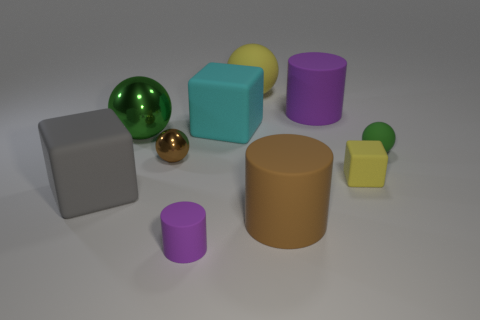Subtract all gray matte cubes. How many cubes are left? 2 Subtract all brown cylinders. How many green spheres are left? 2 Subtract all brown spheres. How many spheres are left? 3 Subtract 3 spheres. How many spheres are left? 1 Subtract all balls. How many objects are left? 6 Add 2 cylinders. How many cylinders exist? 5 Subtract 0 red balls. How many objects are left? 10 Subtract all blue cylinders. Subtract all yellow balls. How many cylinders are left? 3 Subtract all large purple cylinders. Subtract all spheres. How many objects are left? 5 Add 9 brown balls. How many brown balls are left? 10 